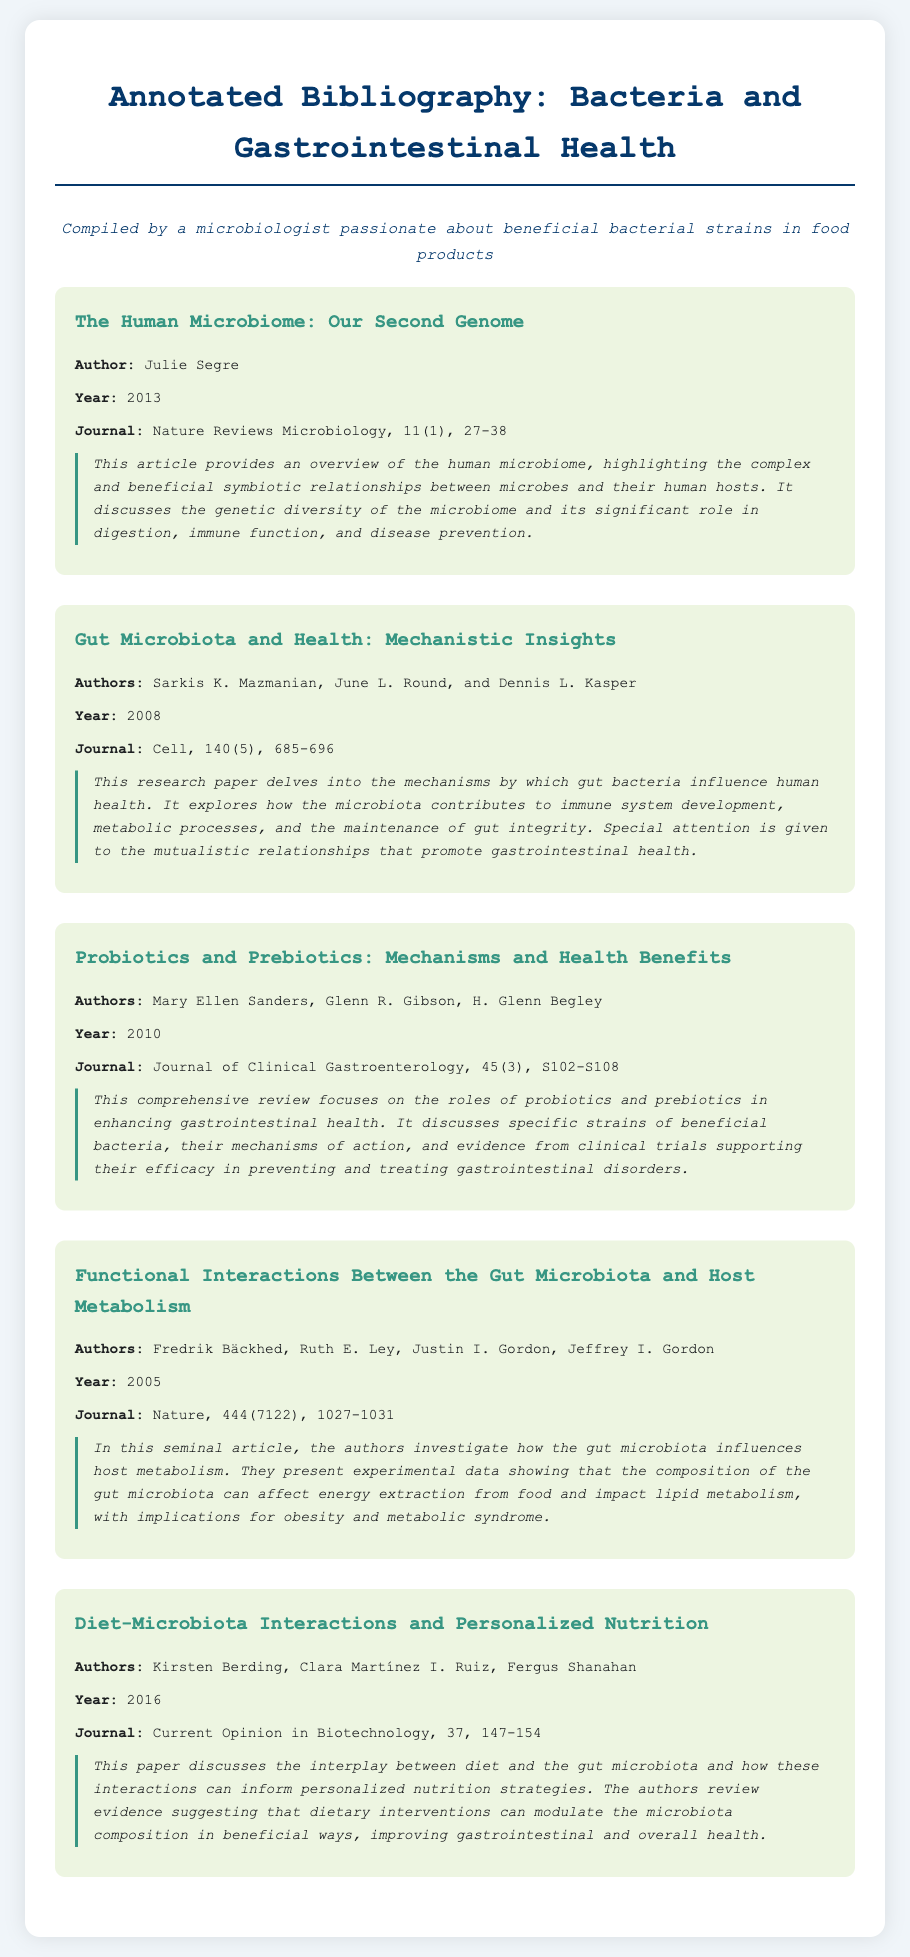what is the title of the first article? The title of the first article is mentioned at the start of its entry in the document.
Answer: The Human Microbiome: Our Second Genome who is the author of the second article? The author's name is provided under the title of the second article in the bibliography.
Answer: Sarkis K. Mazmanian what year was the third article published? The publication year is listed alongside the article details in the bibliography.
Answer: 2010 which journal published the fourth article? The journal name is stated in the bibliographic details of the fourth entry.
Answer: Nature what is the focus of the last article? The summary provided gives insight into the main topic of the last article presented in the bibliography.
Answer: Diet and microbiota interactions how many authors are listed for the first article? The number of authors is indicated under the article details in the bibliography.
Answer: One which article discusses probiotics and prebiotics? The titles of the articles provide insights into their topics as stated in the document.
Answer: Probiotics and Prebiotics: Mechanisms and Health Benefits what type of document is this? The title and content structure indicate the nature of the document.
Answer: Annotated Bibliography 